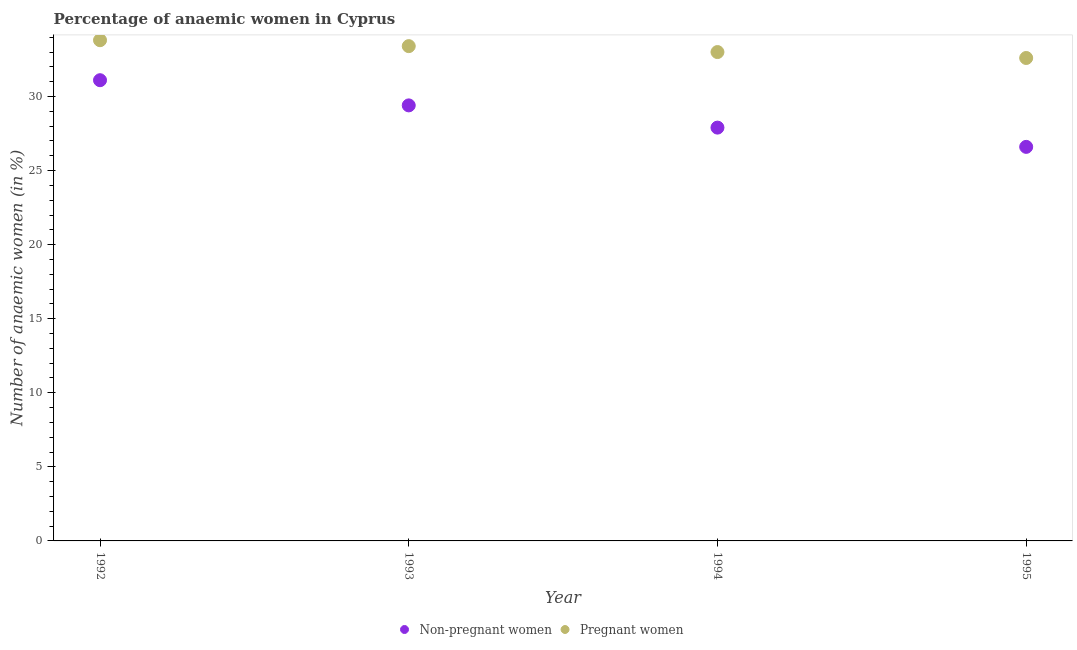Is the number of dotlines equal to the number of legend labels?
Make the answer very short. Yes. What is the percentage of pregnant anaemic women in 1995?
Your answer should be compact. 32.6. Across all years, what is the maximum percentage of pregnant anaemic women?
Your response must be concise. 33.8. Across all years, what is the minimum percentage of pregnant anaemic women?
Provide a short and direct response. 32.6. In which year was the percentage of non-pregnant anaemic women maximum?
Your response must be concise. 1992. In which year was the percentage of non-pregnant anaemic women minimum?
Make the answer very short. 1995. What is the total percentage of pregnant anaemic women in the graph?
Provide a succinct answer. 132.8. What is the difference between the percentage of pregnant anaemic women in 1994 and that in 1995?
Offer a terse response. 0.4. What is the difference between the percentage of pregnant anaemic women in 1992 and the percentage of non-pregnant anaemic women in 1995?
Provide a succinct answer. 7.2. What is the average percentage of non-pregnant anaemic women per year?
Offer a terse response. 28.75. In the year 1995, what is the difference between the percentage of non-pregnant anaemic women and percentage of pregnant anaemic women?
Your answer should be very brief. -6. What is the ratio of the percentage of pregnant anaemic women in 1992 to that in 1993?
Ensure brevity in your answer.  1.01. What is the difference between the highest and the second highest percentage of non-pregnant anaemic women?
Keep it short and to the point. 1.7. What is the difference between the highest and the lowest percentage of pregnant anaemic women?
Offer a very short reply. 1.2. Is the percentage of pregnant anaemic women strictly less than the percentage of non-pregnant anaemic women over the years?
Provide a succinct answer. No. How many dotlines are there?
Your answer should be very brief. 2. How many years are there in the graph?
Provide a short and direct response. 4. What is the difference between two consecutive major ticks on the Y-axis?
Your answer should be very brief. 5. How are the legend labels stacked?
Keep it short and to the point. Horizontal. What is the title of the graph?
Offer a very short reply. Percentage of anaemic women in Cyprus. Does "Short-term debt" appear as one of the legend labels in the graph?
Your answer should be very brief. No. What is the label or title of the X-axis?
Your answer should be compact. Year. What is the label or title of the Y-axis?
Keep it short and to the point. Number of anaemic women (in %). What is the Number of anaemic women (in %) in Non-pregnant women in 1992?
Give a very brief answer. 31.1. What is the Number of anaemic women (in %) of Pregnant women in 1992?
Keep it short and to the point. 33.8. What is the Number of anaemic women (in %) in Non-pregnant women in 1993?
Provide a short and direct response. 29.4. What is the Number of anaemic women (in %) in Pregnant women in 1993?
Provide a succinct answer. 33.4. What is the Number of anaemic women (in %) of Non-pregnant women in 1994?
Provide a succinct answer. 27.9. What is the Number of anaemic women (in %) of Non-pregnant women in 1995?
Ensure brevity in your answer.  26.6. What is the Number of anaemic women (in %) in Pregnant women in 1995?
Provide a short and direct response. 32.6. Across all years, what is the maximum Number of anaemic women (in %) in Non-pregnant women?
Your answer should be very brief. 31.1. Across all years, what is the maximum Number of anaemic women (in %) in Pregnant women?
Offer a very short reply. 33.8. Across all years, what is the minimum Number of anaemic women (in %) of Non-pregnant women?
Your answer should be very brief. 26.6. Across all years, what is the minimum Number of anaemic women (in %) of Pregnant women?
Keep it short and to the point. 32.6. What is the total Number of anaemic women (in %) in Non-pregnant women in the graph?
Offer a very short reply. 115. What is the total Number of anaemic women (in %) in Pregnant women in the graph?
Offer a very short reply. 132.8. What is the difference between the Number of anaemic women (in %) of Non-pregnant women in 1992 and that in 1994?
Your response must be concise. 3.2. What is the difference between the Number of anaemic women (in %) in Pregnant women in 1992 and that in 1994?
Keep it short and to the point. 0.8. What is the difference between the Number of anaemic women (in %) of Non-pregnant women in 1992 and that in 1995?
Offer a terse response. 4.5. What is the difference between the Number of anaemic women (in %) in Pregnant women in 1992 and that in 1995?
Offer a terse response. 1.2. What is the difference between the Number of anaemic women (in %) in Pregnant women in 1993 and that in 1994?
Your answer should be very brief. 0.4. What is the difference between the Number of anaemic women (in %) in Pregnant women in 1994 and that in 1995?
Provide a short and direct response. 0.4. What is the difference between the Number of anaemic women (in %) of Non-pregnant women in 1992 and the Number of anaemic women (in %) of Pregnant women in 1994?
Give a very brief answer. -1.9. What is the difference between the Number of anaemic women (in %) of Non-pregnant women in 1993 and the Number of anaemic women (in %) of Pregnant women in 1994?
Your response must be concise. -3.6. What is the difference between the Number of anaemic women (in %) in Non-pregnant women in 1994 and the Number of anaemic women (in %) in Pregnant women in 1995?
Your answer should be very brief. -4.7. What is the average Number of anaemic women (in %) of Non-pregnant women per year?
Make the answer very short. 28.75. What is the average Number of anaemic women (in %) in Pregnant women per year?
Make the answer very short. 33.2. In the year 1994, what is the difference between the Number of anaemic women (in %) of Non-pregnant women and Number of anaemic women (in %) of Pregnant women?
Give a very brief answer. -5.1. In the year 1995, what is the difference between the Number of anaemic women (in %) in Non-pregnant women and Number of anaemic women (in %) in Pregnant women?
Keep it short and to the point. -6. What is the ratio of the Number of anaemic women (in %) in Non-pregnant women in 1992 to that in 1993?
Keep it short and to the point. 1.06. What is the ratio of the Number of anaemic women (in %) in Non-pregnant women in 1992 to that in 1994?
Offer a very short reply. 1.11. What is the ratio of the Number of anaemic women (in %) of Pregnant women in 1992 to that in 1994?
Keep it short and to the point. 1.02. What is the ratio of the Number of anaemic women (in %) of Non-pregnant women in 1992 to that in 1995?
Provide a short and direct response. 1.17. What is the ratio of the Number of anaemic women (in %) in Pregnant women in 1992 to that in 1995?
Offer a very short reply. 1.04. What is the ratio of the Number of anaemic women (in %) of Non-pregnant women in 1993 to that in 1994?
Offer a terse response. 1.05. What is the ratio of the Number of anaemic women (in %) of Pregnant women in 1993 to that in 1994?
Make the answer very short. 1.01. What is the ratio of the Number of anaemic women (in %) in Non-pregnant women in 1993 to that in 1995?
Give a very brief answer. 1.11. What is the ratio of the Number of anaemic women (in %) of Pregnant women in 1993 to that in 1995?
Provide a short and direct response. 1.02. What is the ratio of the Number of anaemic women (in %) of Non-pregnant women in 1994 to that in 1995?
Give a very brief answer. 1.05. What is the ratio of the Number of anaemic women (in %) of Pregnant women in 1994 to that in 1995?
Keep it short and to the point. 1.01. What is the difference between the highest and the second highest Number of anaemic women (in %) in Non-pregnant women?
Offer a very short reply. 1.7. 